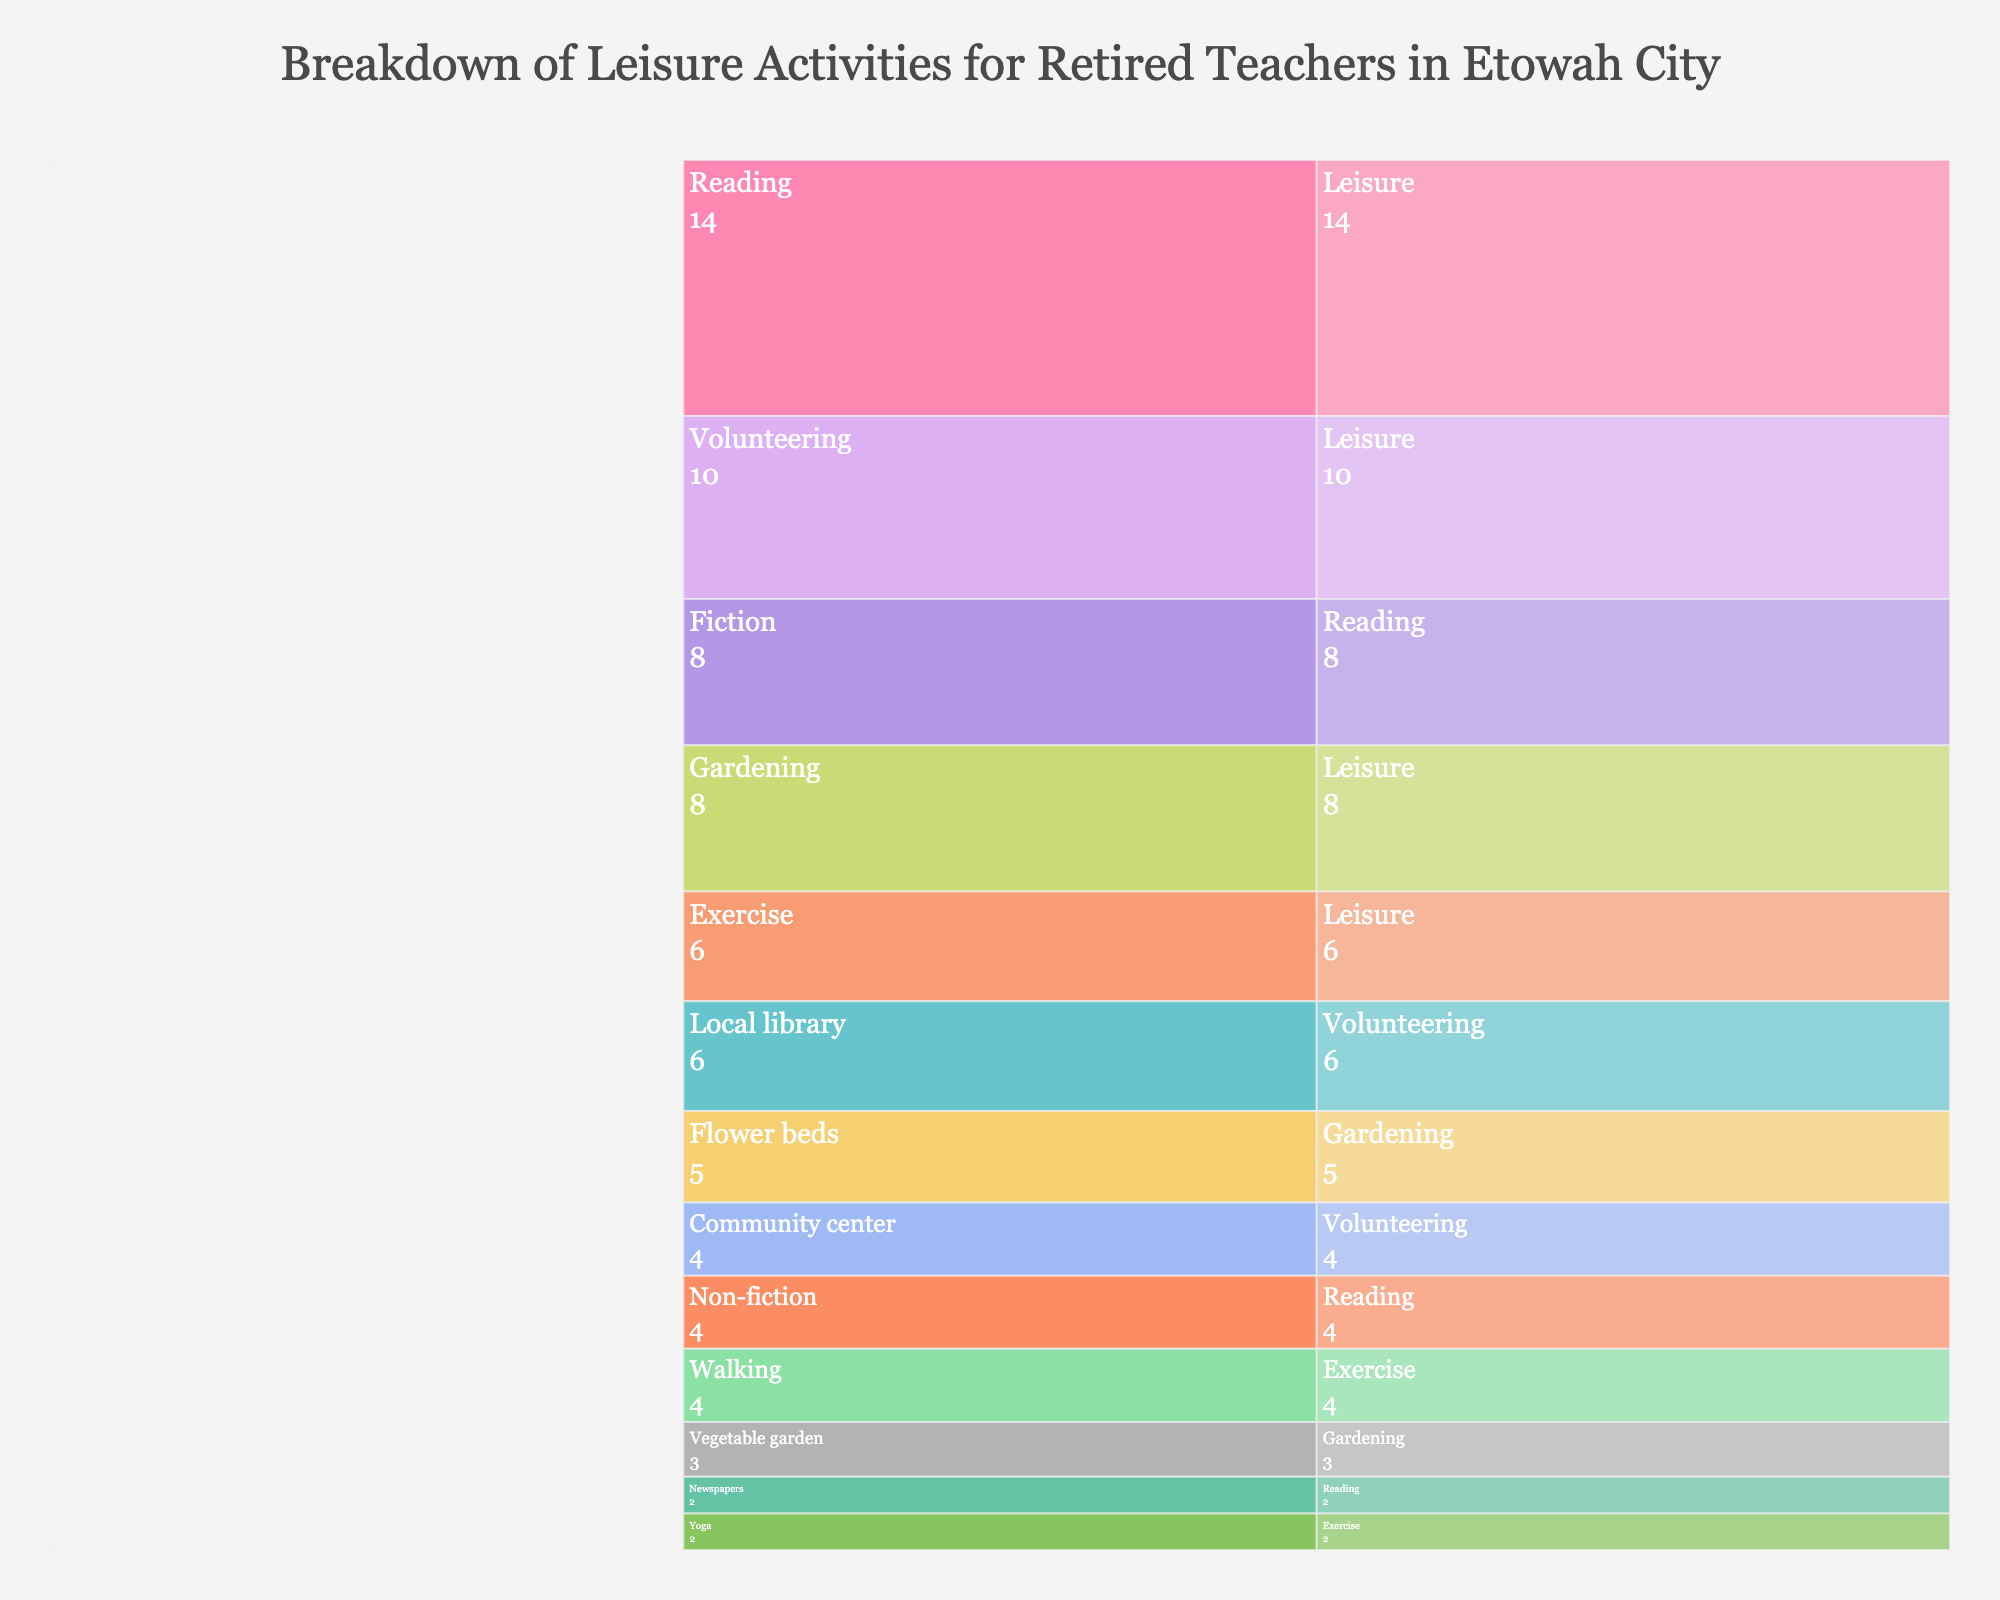What is the main title of the chart? The title is usually displayed at the top of the chart and should be clearly visible.
Answer: Breakdown of Leisure Activities for Retired Teachers in Etowah City How many hours per week are spent on reading in total? Sum up the hours spent on Fiction, Non-fiction, and Newspapers under the Reading category. 8 + 4 + 2 = 14 hours
Answer: 14 hours Which activity within Volunteering takes up the most hours per week? Compare the hours for Local library and Community center under Volunteering. Local library has 6 hours, and Community center has 4 hours.
Answer: Local library How much more time is spent on Reading compared to Exercise? Subtract the total hours spent on Exercise from the total hours spent on Reading. 14 (Reading) - 6 (Exercise) = 8
Answer: 8 hours Which category has the least hours spent per week? Compare the total hours of Reading, Gardening, Exercise, and Volunteering. Exercise has the least with 6 hours.
Answer: Exercise What is the proportion of time spent on Fiction relative to the total time spent on Reading? Divide the hours spent on Fiction by the total hours spent on Reading. 8 / 14 ≈ 0.57
Answer: Approximately 0.57 Between Gardening and Volunteering, which activity has more hours per week? Compare the total hours of Gardening (8 hours) and Volunteering (10 hours).
Answer: Volunteering How many hours per week are spent on activities related to Community engagement (Volunteering and Gardening)? Sum the hours spent on Volunteering with the hours spent on Gardening. 10 + 8 = 18 hours
Answer: 18 hours Which specific activity within Gardening takes less time per week, Flower beds or Vegetable garden? Compare the hours for Flower beds and Vegetable garden under Gardening. Flower beds have 5 hours, and Vegetable garden has 3 hours.
Answer: Vegetable garden Is the time spent on Yoga more or less than the time spent on Non-fiction reading? Compare the hours spent on Yoga (2 hours) with Non-fiction reading (4 hours).
Answer: Less 